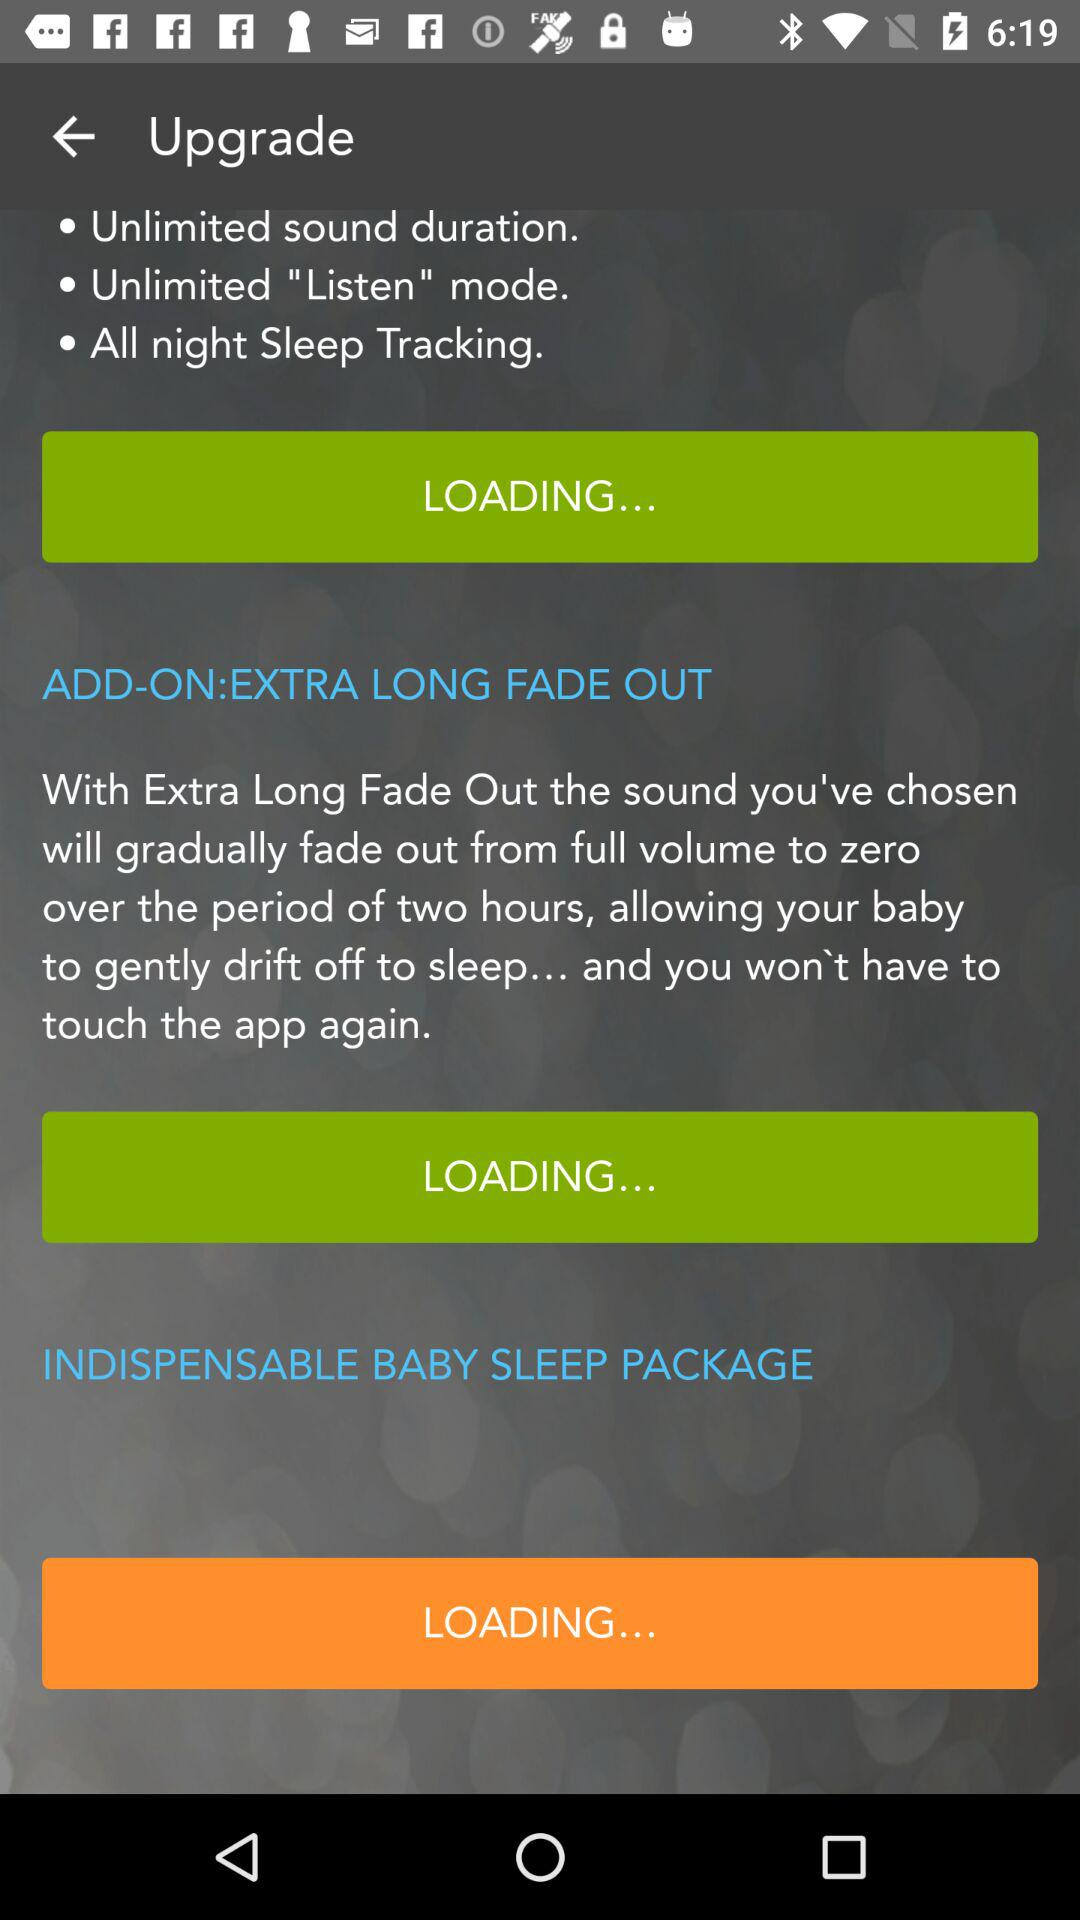How many hours does the Extra Long Fade Out feature last?
Answer the question using a single word or phrase. 2 